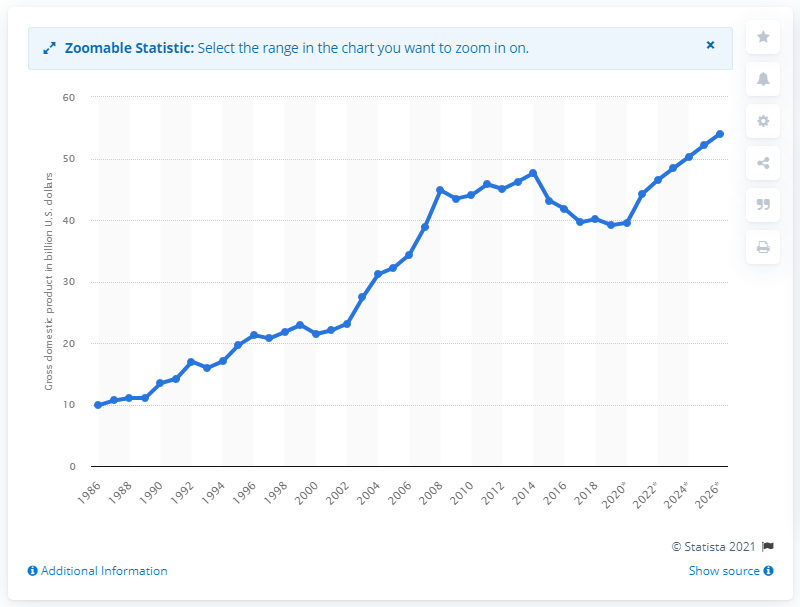Highlight a few significant elements in this photo. In 2019, Tunisia's gross domestic product was 39.55. 